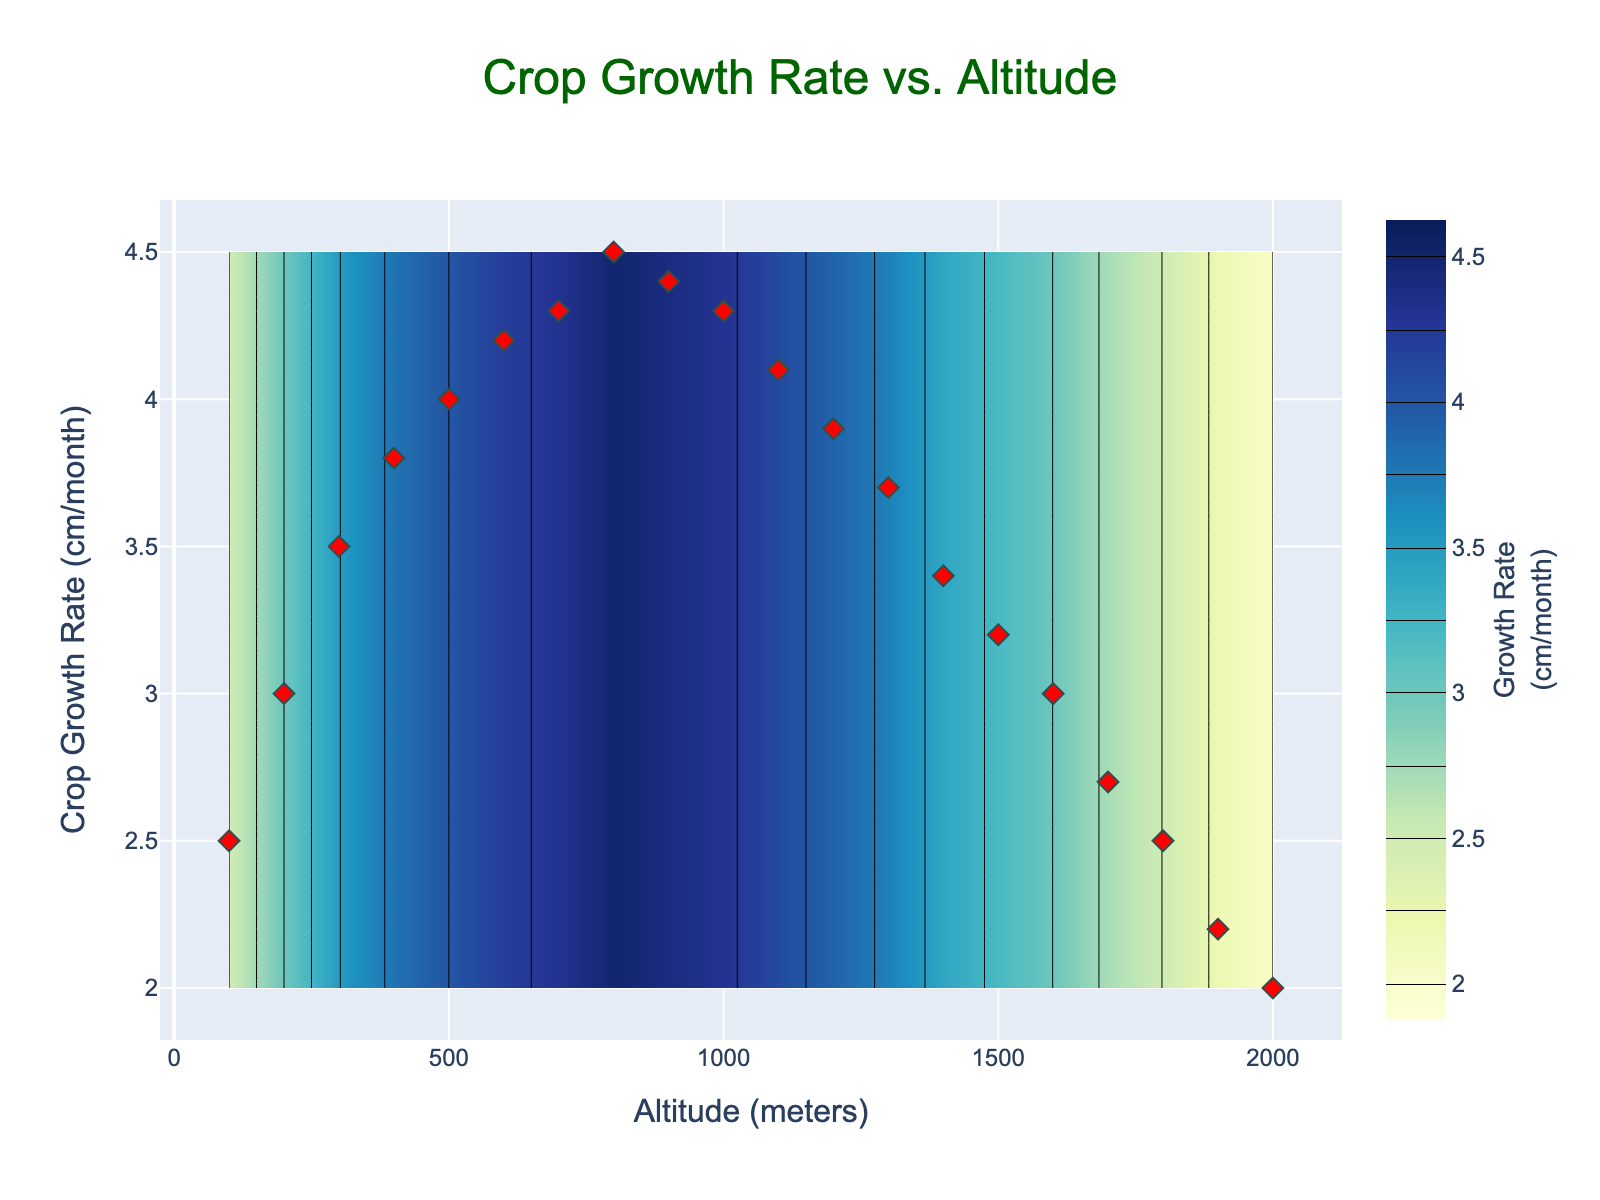what is the title of the figure? The title of the figure is displayed at the top. It reads "Crop Growth Rate vs. Altitude".
Answer: Crop Growth Rate vs. Altitude What are the units of the x-axis? The units of the x-axis are written next to the axis label, which reads "Altitude (meters)".
Answer: meters What color is used to represent higher growth rates in the contour plot? Higher growth rates are represented by lighter colors. In this plot, lighter shades of the color scale 'YlGnBu' are used to denote higher growth rates.
Answer: light blue Between what altitude range does the crop growth rate reach its highest value? From the scatter plot, it is clear that crop growth rate peaks around 800 meters, as indicated by one of the red dots representing the highest value.
Answer: around 800 meters How many data points are plotted on the scatter plot? The number of red dots in the scatter plot corresponds to the number of data points. Counting the red dots gives a total of 20 data points.
Answer: 20 At what altitude does the crop growth rate begin to decline? From the scatter plot and contour lines, it is evident that the crop growth rate starts to decline after reaching its highest point around 800 meters.
Answer: after 800 meters What is the crop growth rate at 100 meters? The first red dot on the scatter plot at 100 meters shows a crop growth rate of around 2.5 cm/month, as indicated on the y-axis.
Answer: 2.5 cm/month Which altitude has a higher crop growth rate: 500 meters or 1500 meters? By comparing the red dots at 500 meters and 1500 meters on the scatter plot, the altitude of 500 meters has a higher crop growth rate.
Answer: 500 meters By how much does the crop growth rate decrease from 800 meters to 2000 meters? At 800 meters, the growth rate is around 4.5 cm/month, and at 2000 meters, it is 2.0 cm/month. The decrease is 4.5 - 2.0 = 2.5 cm/month.
Answer: 2.5 cm/month What is the size interval used in the contour lines to represent changes in growth rate? The contour lines have intervals representing changes in growth rate as indicated in the legend. The interval size is 0.25 cm/month.
Answer: 0.25 cm/month 